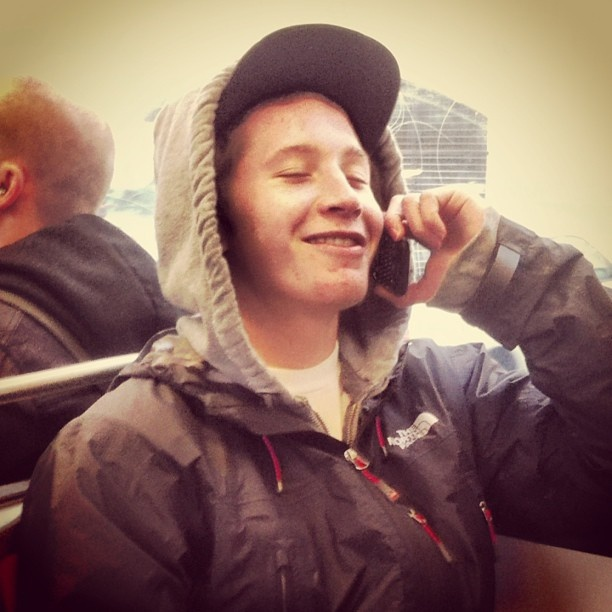Describe the objects in this image and their specific colors. I can see people in tan, maroon, black, and brown tones, people in tan, brown, and maroon tones, and cell phone in tan, maroon, black, gray, and brown tones in this image. 